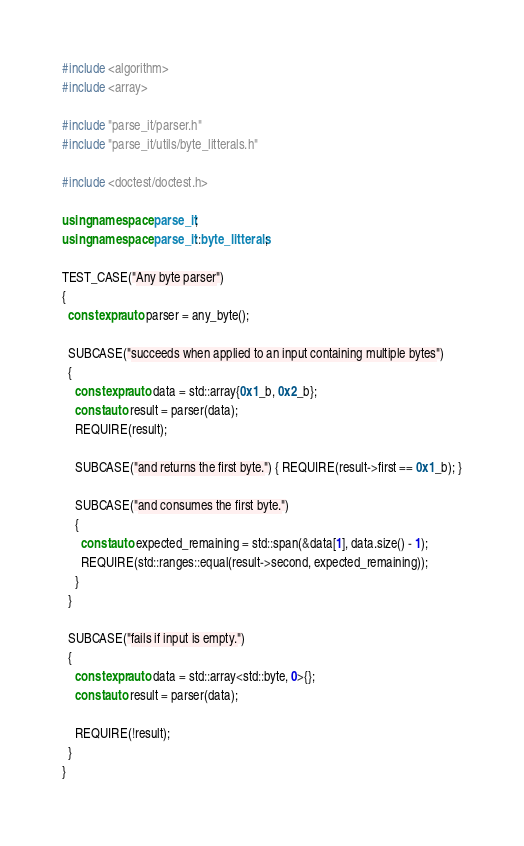<code> <loc_0><loc_0><loc_500><loc_500><_C++_>#include <algorithm>
#include <array>

#include "parse_it/parser.h"
#include "parse_it/utils/byte_litterals.h"

#include <doctest/doctest.h>

using namespace parse_it;
using namespace parse_it::byte_litterals;

TEST_CASE("Any byte parser")
{
  constexpr auto parser = any_byte();

  SUBCASE("succeeds when applied to an input containing multiple bytes")
  {
    constexpr auto data = std::array{0x1_b, 0x2_b};
    const auto result = parser(data);
    REQUIRE(result);

    SUBCASE("and returns the first byte.") { REQUIRE(result->first == 0x1_b); }

    SUBCASE("and consumes the first byte.")
    {
      const auto expected_remaining = std::span(&data[1], data.size() - 1);
      REQUIRE(std::ranges::equal(result->second, expected_remaining));
    }
  }

  SUBCASE("fails if input is empty.")
  {
    constexpr auto data = std::array<std::byte, 0>{};
    const auto result = parser(data);

    REQUIRE(!result);
  }
}
</code> 